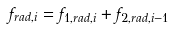Convert formula to latex. <formula><loc_0><loc_0><loc_500><loc_500>f _ { r a d , i } = f _ { 1 , r a d , i } + f _ { 2 , r a d , i - 1 }</formula> 